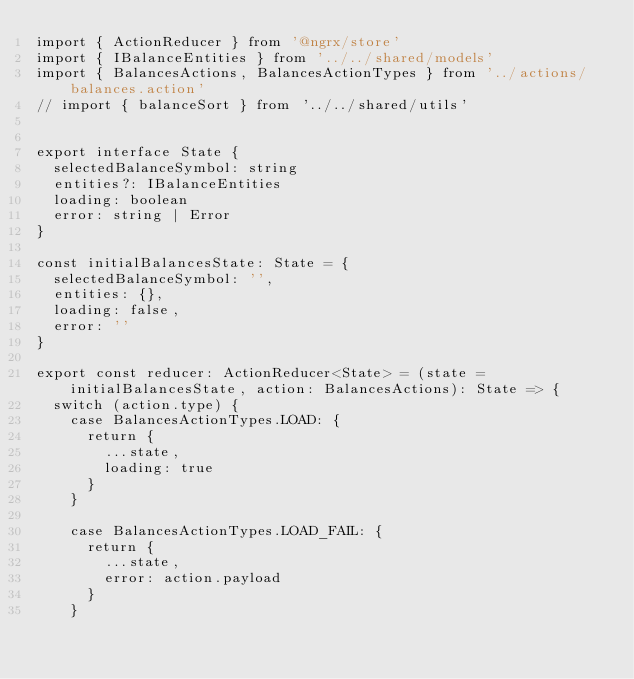Convert code to text. <code><loc_0><loc_0><loc_500><loc_500><_TypeScript_>import { ActionReducer } from '@ngrx/store'
import { IBalanceEntities } from '../../shared/models'
import { BalancesActions, BalancesActionTypes } from '../actions/balances.action'
// import { balanceSort } from '../../shared/utils'


export interface State {
	selectedBalanceSymbol: string
	entities?: IBalanceEntities
	loading: boolean
	error: string | Error
}

const initialBalancesState: State = {
	selectedBalanceSymbol: '',
	entities: {},
	loading: false,
	error: ''
}

export const reducer: ActionReducer<State> = (state = initialBalancesState, action: BalancesActions): State => {
	switch (action.type) {
		case BalancesActionTypes.LOAD: {
			return {
				...state,
				loading: true
			}
		}

		case BalancesActionTypes.LOAD_FAIL: {
			return {
				...state,
				error: action.payload
			}
		}
</code> 